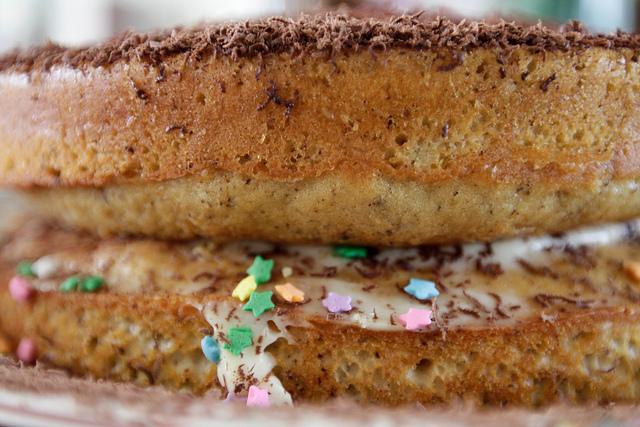What flavors would one expect from this food?
Short answer required. Sweet. Is this a bagel?
Write a very short answer. No. What are the colorful stars for?
Answer briefly. Decoration. 